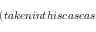Convert formula to latex. <formula><loc_0><loc_0><loc_500><loc_500>( t a k e n i n t h i s c a s e a s</formula> 